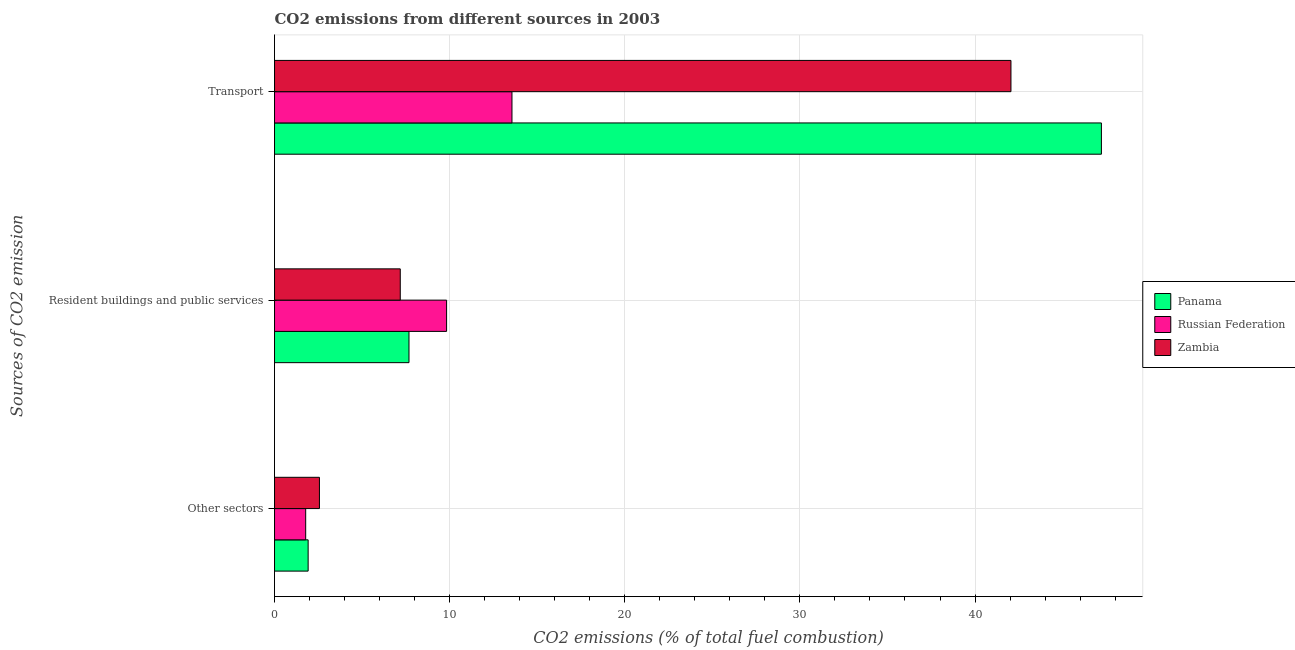How many different coloured bars are there?
Ensure brevity in your answer.  3. Are the number of bars per tick equal to the number of legend labels?
Keep it short and to the point. Yes. How many bars are there on the 3rd tick from the top?
Your answer should be compact. 3. How many bars are there on the 3rd tick from the bottom?
Keep it short and to the point. 3. What is the label of the 1st group of bars from the top?
Provide a short and direct response. Transport. What is the percentage of co2 emissions from resident buildings and public services in Russian Federation?
Provide a short and direct response. 9.83. Across all countries, what is the maximum percentage of co2 emissions from other sectors?
Ensure brevity in your answer.  2.56. Across all countries, what is the minimum percentage of co2 emissions from transport?
Keep it short and to the point. 13.56. In which country was the percentage of co2 emissions from other sectors maximum?
Ensure brevity in your answer.  Zambia. In which country was the percentage of co2 emissions from other sectors minimum?
Offer a very short reply. Russian Federation. What is the total percentage of co2 emissions from transport in the graph?
Your response must be concise. 102.83. What is the difference between the percentage of co2 emissions from resident buildings and public services in Zambia and that in Panama?
Your response must be concise. -0.5. What is the difference between the percentage of co2 emissions from resident buildings and public services in Zambia and the percentage of co2 emissions from other sectors in Russian Federation?
Make the answer very short. 5.4. What is the average percentage of co2 emissions from resident buildings and public services per country?
Offer a very short reply. 8.23. What is the difference between the percentage of co2 emissions from resident buildings and public services and percentage of co2 emissions from transport in Zambia?
Keep it short and to the point. -34.87. In how many countries, is the percentage of co2 emissions from transport greater than 2 %?
Keep it short and to the point. 3. What is the ratio of the percentage of co2 emissions from other sectors in Zambia to that in Panama?
Provide a short and direct response. 1.34. Is the percentage of co2 emissions from other sectors in Zambia less than that in Panama?
Your answer should be compact. No. What is the difference between the highest and the second highest percentage of co2 emissions from transport?
Your answer should be compact. 5.17. What is the difference between the highest and the lowest percentage of co2 emissions from transport?
Make the answer very short. 33.66. What does the 1st bar from the top in Transport represents?
Keep it short and to the point. Zambia. What does the 1st bar from the bottom in Transport represents?
Give a very brief answer. Panama. Is it the case that in every country, the sum of the percentage of co2 emissions from other sectors and percentage of co2 emissions from resident buildings and public services is greater than the percentage of co2 emissions from transport?
Give a very brief answer. No. How many bars are there?
Keep it short and to the point. 9. How many countries are there in the graph?
Provide a short and direct response. 3. Are the values on the major ticks of X-axis written in scientific E-notation?
Your response must be concise. No. Does the graph contain any zero values?
Keep it short and to the point. No. Does the graph contain grids?
Provide a short and direct response. Yes. What is the title of the graph?
Offer a very short reply. CO2 emissions from different sources in 2003. Does "Liberia" appear as one of the legend labels in the graph?
Your answer should be very brief. No. What is the label or title of the X-axis?
Offer a terse response. CO2 emissions (% of total fuel combustion). What is the label or title of the Y-axis?
Your answer should be compact. Sources of CO2 emission. What is the CO2 emissions (% of total fuel combustion) of Panama in Other sectors?
Ensure brevity in your answer.  1.92. What is the CO2 emissions (% of total fuel combustion) of Russian Federation in Other sectors?
Make the answer very short. 1.78. What is the CO2 emissions (% of total fuel combustion) of Zambia in Other sectors?
Keep it short and to the point. 2.56. What is the CO2 emissions (% of total fuel combustion) in Panama in Resident buildings and public services?
Your answer should be compact. 7.68. What is the CO2 emissions (% of total fuel combustion) in Russian Federation in Resident buildings and public services?
Provide a short and direct response. 9.83. What is the CO2 emissions (% of total fuel combustion) of Zambia in Resident buildings and public services?
Keep it short and to the point. 7.18. What is the CO2 emissions (% of total fuel combustion) in Panama in Transport?
Your response must be concise. 47.22. What is the CO2 emissions (% of total fuel combustion) in Russian Federation in Transport?
Offer a terse response. 13.56. What is the CO2 emissions (% of total fuel combustion) of Zambia in Transport?
Offer a terse response. 42.05. Across all Sources of CO2 emission, what is the maximum CO2 emissions (% of total fuel combustion) in Panama?
Keep it short and to the point. 47.22. Across all Sources of CO2 emission, what is the maximum CO2 emissions (% of total fuel combustion) in Russian Federation?
Give a very brief answer. 13.56. Across all Sources of CO2 emission, what is the maximum CO2 emissions (% of total fuel combustion) of Zambia?
Your answer should be very brief. 42.05. Across all Sources of CO2 emission, what is the minimum CO2 emissions (% of total fuel combustion) of Panama?
Ensure brevity in your answer.  1.92. Across all Sources of CO2 emission, what is the minimum CO2 emissions (% of total fuel combustion) of Russian Federation?
Offer a terse response. 1.78. Across all Sources of CO2 emission, what is the minimum CO2 emissions (% of total fuel combustion) in Zambia?
Your answer should be compact. 2.56. What is the total CO2 emissions (% of total fuel combustion) of Panama in the graph?
Give a very brief answer. 56.81. What is the total CO2 emissions (% of total fuel combustion) in Russian Federation in the graph?
Provide a short and direct response. 25.16. What is the total CO2 emissions (% of total fuel combustion) in Zambia in the graph?
Offer a very short reply. 51.79. What is the difference between the CO2 emissions (% of total fuel combustion) in Panama in Other sectors and that in Resident buildings and public services?
Your answer should be very brief. -5.76. What is the difference between the CO2 emissions (% of total fuel combustion) of Russian Federation in Other sectors and that in Resident buildings and public services?
Your answer should be compact. -8.05. What is the difference between the CO2 emissions (% of total fuel combustion) of Zambia in Other sectors and that in Resident buildings and public services?
Your answer should be very brief. -4.62. What is the difference between the CO2 emissions (% of total fuel combustion) in Panama in Other sectors and that in Transport?
Give a very brief answer. -45.3. What is the difference between the CO2 emissions (% of total fuel combustion) in Russian Federation in Other sectors and that in Transport?
Ensure brevity in your answer.  -11.78. What is the difference between the CO2 emissions (% of total fuel combustion) of Zambia in Other sectors and that in Transport?
Ensure brevity in your answer.  -39.49. What is the difference between the CO2 emissions (% of total fuel combustion) of Panama in Resident buildings and public services and that in Transport?
Provide a succinct answer. -39.54. What is the difference between the CO2 emissions (% of total fuel combustion) of Russian Federation in Resident buildings and public services and that in Transport?
Make the answer very short. -3.73. What is the difference between the CO2 emissions (% of total fuel combustion) of Zambia in Resident buildings and public services and that in Transport?
Offer a terse response. -34.87. What is the difference between the CO2 emissions (% of total fuel combustion) of Panama in Other sectors and the CO2 emissions (% of total fuel combustion) of Russian Federation in Resident buildings and public services?
Your answer should be compact. -7.91. What is the difference between the CO2 emissions (% of total fuel combustion) of Panama in Other sectors and the CO2 emissions (% of total fuel combustion) of Zambia in Resident buildings and public services?
Provide a succinct answer. -5.26. What is the difference between the CO2 emissions (% of total fuel combustion) of Russian Federation in Other sectors and the CO2 emissions (% of total fuel combustion) of Zambia in Resident buildings and public services?
Give a very brief answer. -5.4. What is the difference between the CO2 emissions (% of total fuel combustion) in Panama in Other sectors and the CO2 emissions (% of total fuel combustion) in Russian Federation in Transport?
Provide a short and direct response. -11.64. What is the difference between the CO2 emissions (% of total fuel combustion) of Panama in Other sectors and the CO2 emissions (% of total fuel combustion) of Zambia in Transport?
Provide a short and direct response. -40.13. What is the difference between the CO2 emissions (% of total fuel combustion) of Russian Federation in Other sectors and the CO2 emissions (% of total fuel combustion) of Zambia in Transport?
Keep it short and to the point. -40.27. What is the difference between the CO2 emissions (% of total fuel combustion) in Panama in Resident buildings and public services and the CO2 emissions (% of total fuel combustion) in Russian Federation in Transport?
Provide a short and direct response. -5.88. What is the difference between the CO2 emissions (% of total fuel combustion) of Panama in Resident buildings and public services and the CO2 emissions (% of total fuel combustion) of Zambia in Transport?
Offer a terse response. -34.37. What is the difference between the CO2 emissions (% of total fuel combustion) in Russian Federation in Resident buildings and public services and the CO2 emissions (% of total fuel combustion) in Zambia in Transport?
Ensure brevity in your answer.  -32.23. What is the average CO2 emissions (% of total fuel combustion) in Panama per Sources of CO2 emission?
Provide a short and direct response. 18.94. What is the average CO2 emissions (% of total fuel combustion) of Russian Federation per Sources of CO2 emission?
Offer a terse response. 8.39. What is the average CO2 emissions (% of total fuel combustion) of Zambia per Sources of CO2 emission?
Give a very brief answer. 17.27. What is the difference between the CO2 emissions (% of total fuel combustion) of Panama and CO2 emissions (% of total fuel combustion) of Russian Federation in Other sectors?
Your answer should be very brief. 0.14. What is the difference between the CO2 emissions (% of total fuel combustion) of Panama and CO2 emissions (% of total fuel combustion) of Zambia in Other sectors?
Provide a short and direct response. -0.64. What is the difference between the CO2 emissions (% of total fuel combustion) in Russian Federation and CO2 emissions (% of total fuel combustion) in Zambia in Other sectors?
Provide a short and direct response. -0.79. What is the difference between the CO2 emissions (% of total fuel combustion) in Panama and CO2 emissions (% of total fuel combustion) in Russian Federation in Resident buildings and public services?
Your answer should be very brief. -2.15. What is the difference between the CO2 emissions (% of total fuel combustion) of Panama and CO2 emissions (% of total fuel combustion) of Zambia in Resident buildings and public services?
Keep it short and to the point. 0.5. What is the difference between the CO2 emissions (% of total fuel combustion) in Russian Federation and CO2 emissions (% of total fuel combustion) in Zambia in Resident buildings and public services?
Your answer should be very brief. 2.65. What is the difference between the CO2 emissions (% of total fuel combustion) of Panama and CO2 emissions (% of total fuel combustion) of Russian Federation in Transport?
Offer a very short reply. 33.66. What is the difference between the CO2 emissions (% of total fuel combustion) in Panama and CO2 emissions (% of total fuel combustion) in Zambia in Transport?
Your response must be concise. 5.17. What is the difference between the CO2 emissions (% of total fuel combustion) in Russian Federation and CO2 emissions (% of total fuel combustion) in Zambia in Transport?
Ensure brevity in your answer.  -28.49. What is the ratio of the CO2 emissions (% of total fuel combustion) of Russian Federation in Other sectors to that in Resident buildings and public services?
Make the answer very short. 0.18. What is the ratio of the CO2 emissions (% of total fuel combustion) of Zambia in Other sectors to that in Resident buildings and public services?
Your answer should be compact. 0.36. What is the ratio of the CO2 emissions (% of total fuel combustion) in Panama in Other sectors to that in Transport?
Your response must be concise. 0.04. What is the ratio of the CO2 emissions (% of total fuel combustion) in Russian Federation in Other sectors to that in Transport?
Make the answer very short. 0.13. What is the ratio of the CO2 emissions (% of total fuel combustion) of Zambia in Other sectors to that in Transport?
Your answer should be compact. 0.06. What is the ratio of the CO2 emissions (% of total fuel combustion) of Panama in Resident buildings and public services to that in Transport?
Ensure brevity in your answer.  0.16. What is the ratio of the CO2 emissions (% of total fuel combustion) of Russian Federation in Resident buildings and public services to that in Transport?
Ensure brevity in your answer.  0.72. What is the ratio of the CO2 emissions (% of total fuel combustion) in Zambia in Resident buildings and public services to that in Transport?
Give a very brief answer. 0.17. What is the difference between the highest and the second highest CO2 emissions (% of total fuel combustion) of Panama?
Offer a terse response. 39.54. What is the difference between the highest and the second highest CO2 emissions (% of total fuel combustion) in Russian Federation?
Give a very brief answer. 3.73. What is the difference between the highest and the second highest CO2 emissions (% of total fuel combustion) in Zambia?
Provide a succinct answer. 34.87. What is the difference between the highest and the lowest CO2 emissions (% of total fuel combustion) in Panama?
Your answer should be very brief. 45.3. What is the difference between the highest and the lowest CO2 emissions (% of total fuel combustion) in Russian Federation?
Keep it short and to the point. 11.78. What is the difference between the highest and the lowest CO2 emissions (% of total fuel combustion) in Zambia?
Offer a terse response. 39.49. 